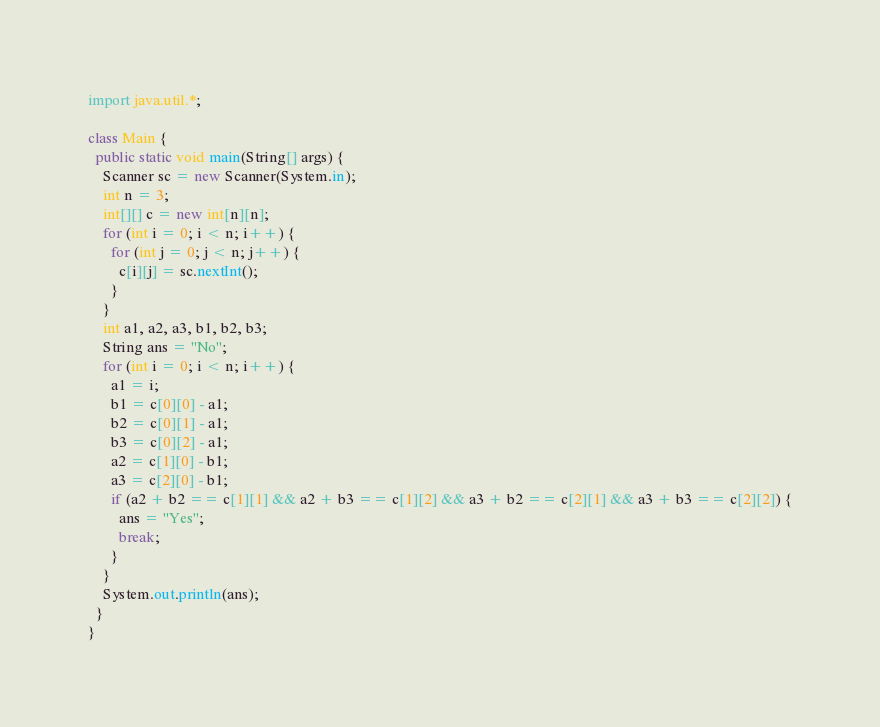Convert code to text. <code><loc_0><loc_0><loc_500><loc_500><_Java_>import java.util.*;

class Main {
  public static void main(String[] args) {
    Scanner sc = new Scanner(System.in);
    int n = 3;
    int[][] c = new int[n][n];
    for (int i = 0; i < n; i++) {
      for (int j = 0; j < n; j++) {
        c[i][j] = sc.nextInt();
      }
    }
    int a1, a2, a3, b1, b2, b3;
    String ans = "No";
    for (int i = 0; i < n; i++) {
      a1 = i;
      b1 = c[0][0] - a1;
      b2 = c[0][1] - a1;
      b3 = c[0][2] - a1;
      a2 = c[1][0] - b1;
      a3 = c[2][0] - b1;
      if (a2 + b2 == c[1][1] && a2 + b3 == c[1][2] && a3 + b2 == c[2][1] && a3 + b3 == c[2][2]) {
        ans = "Yes";
        break;
      }
    }
    System.out.println(ans);
  }
}</code> 